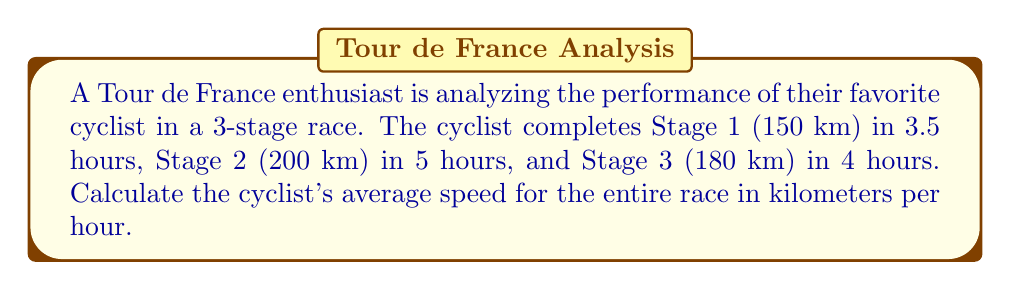Provide a solution to this math problem. To solve this problem, we'll follow these steps:

1. Calculate the total distance:
   $$ \text{Total Distance} = 150 \text{ km} + 200 \text{ km} + 180 \text{ km} = 530 \text{ km} $$

2. Calculate the total time:
   $$ \text{Total Time} = 3.5 \text{ h} + 5 \text{ h} + 4 \text{ h} = 12.5 \text{ h} $$

3. Apply the average speed formula:
   $$ \text{Average Speed} = \frac{\text{Total Distance}}{\text{Total Time}} $$

4. Substitute the values and calculate:
   $$ \text{Average Speed} = \frac{530 \text{ km}}{12.5 \text{ h}} = 42.4 \text{ km/h} $$

Note: The average speed for the entire race is not the same as the average of the individual stage speeds. This method accounts for the different distances of each stage.
Answer: 42.4 km/h 